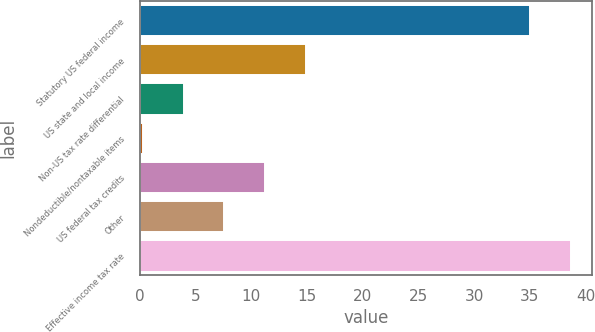Convert chart. <chart><loc_0><loc_0><loc_500><loc_500><bar_chart><fcel>Statutory US federal income<fcel>US state and local income<fcel>Non-US tax rate differential<fcel>Nondeductible/nontaxable items<fcel>US federal tax credits<fcel>Other<fcel>Effective income tax rate<nl><fcel>35<fcel>14.9<fcel>3.95<fcel>0.3<fcel>11.25<fcel>7.6<fcel>38.65<nl></chart> 